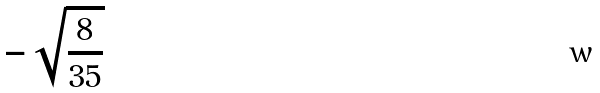<formula> <loc_0><loc_0><loc_500><loc_500>- \sqrt { \frac { 8 } { 3 5 } }</formula> 